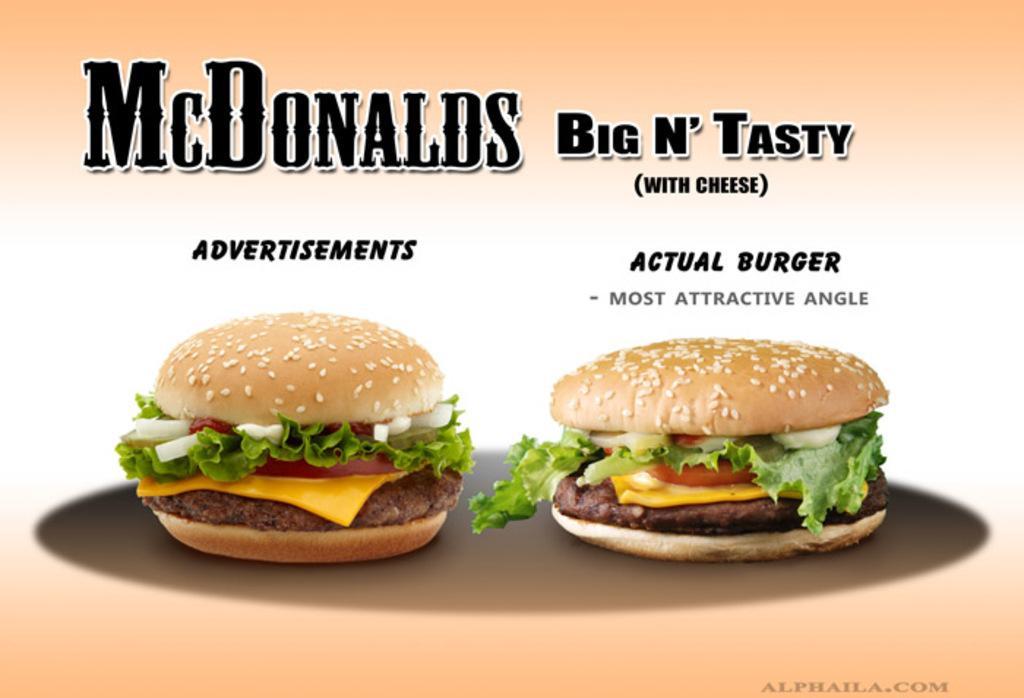Please provide a concise description of this image. In this picture there is a poster. In that poster there are two burgers. In the bottom right corner there is a watermark. At the top I can see the company name. 